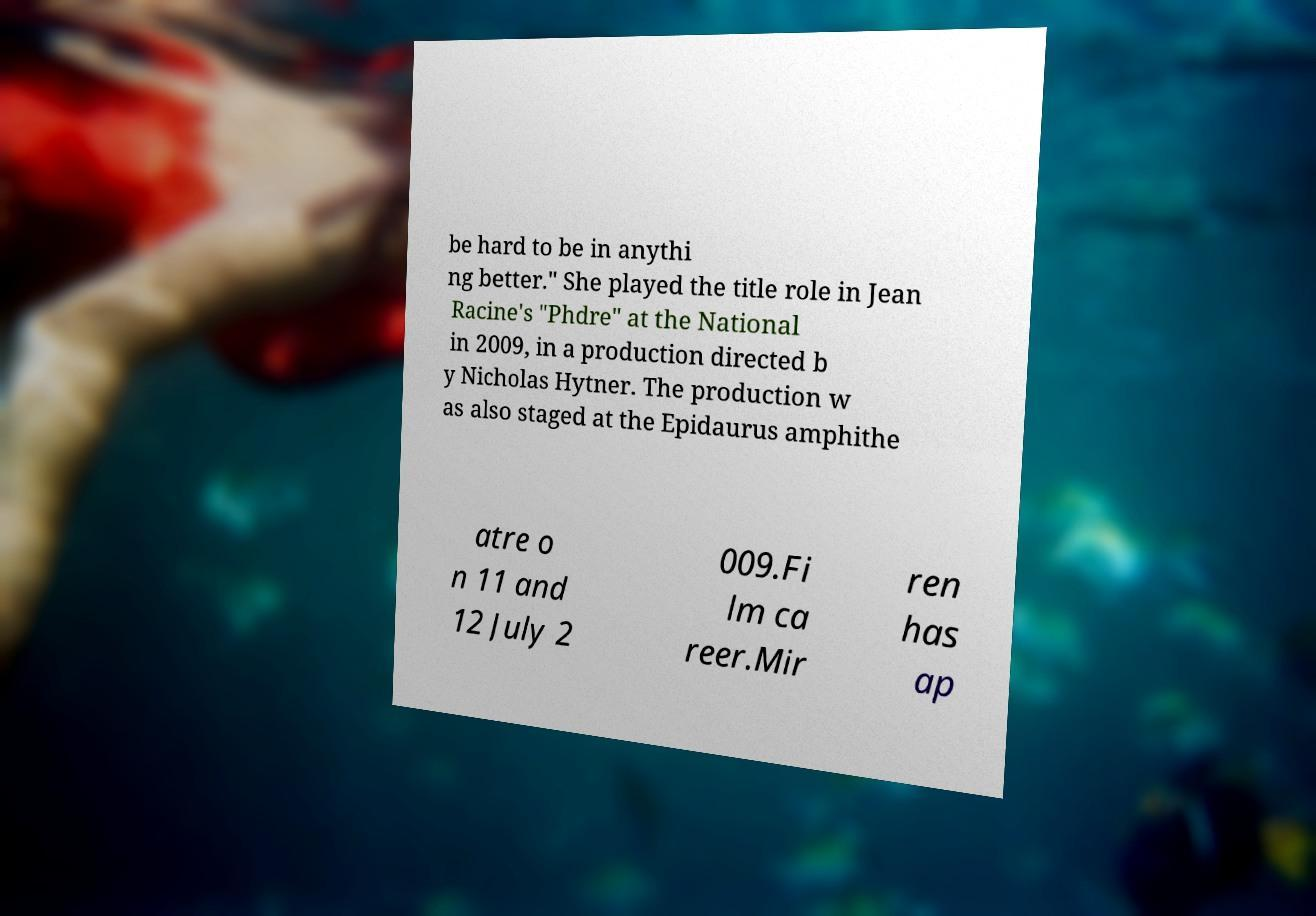Can you accurately transcribe the text from the provided image for me? be hard to be in anythi ng better." She played the title role in Jean Racine's "Phdre" at the National in 2009, in a production directed b y Nicholas Hytner. The production w as also staged at the Epidaurus amphithe atre o n 11 and 12 July 2 009.Fi lm ca reer.Mir ren has ap 